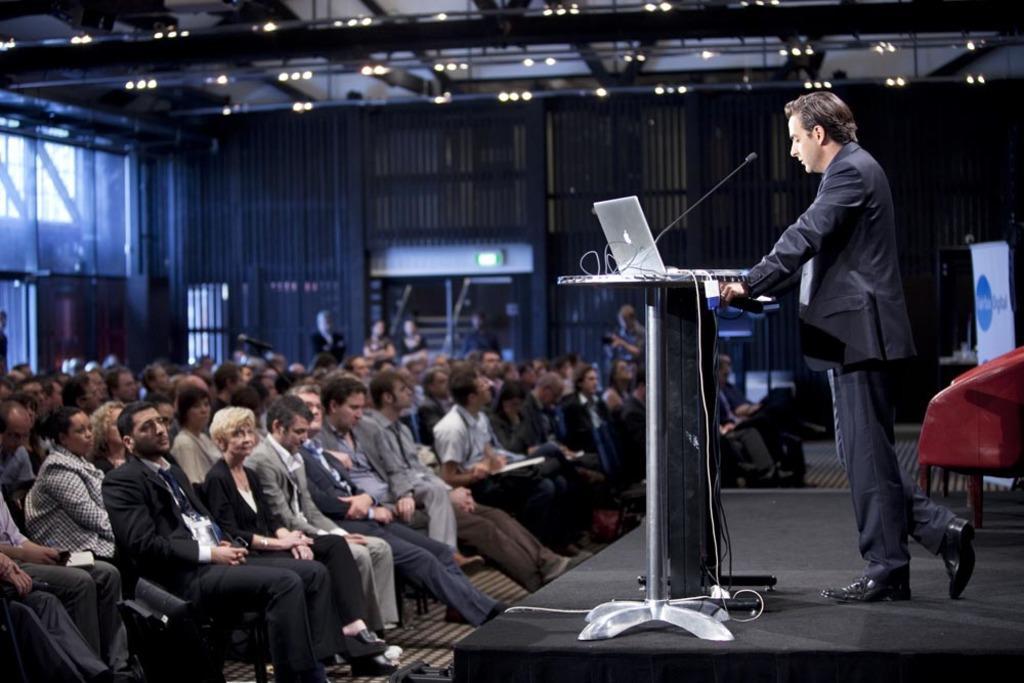In one or two sentences, can you explain what this image depicts? In this image on the left side there are a group of people who are sitting, and on the right side there is one person standing. In front of him there is a podium, on the podium there is laptop and mike and some wires and in the background there are some doors, wall. At the top there is ceiling and some lights, and on the right side there is one chair. At the bottom it looks like a stage. 